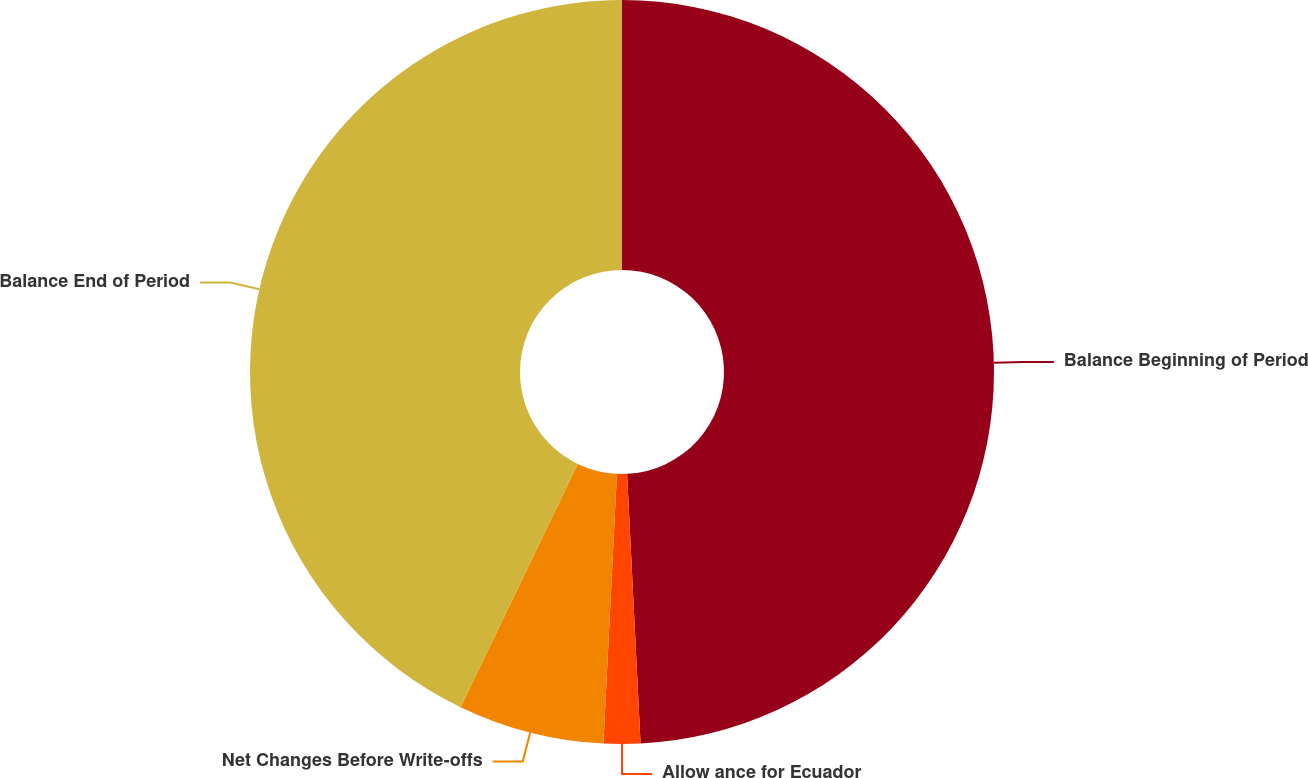Convert chart. <chart><loc_0><loc_0><loc_500><loc_500><pie_chart><fcel>Balance Beginning of Period<fcel>Allow ance for Ecuador<fcel>Net Changes Before Write-offs<fcel>Balance End of Period<nl><fcel>49.21%<fcel>1.59%<fcel>6.35%<fcel>42.86%<nl></chart> 